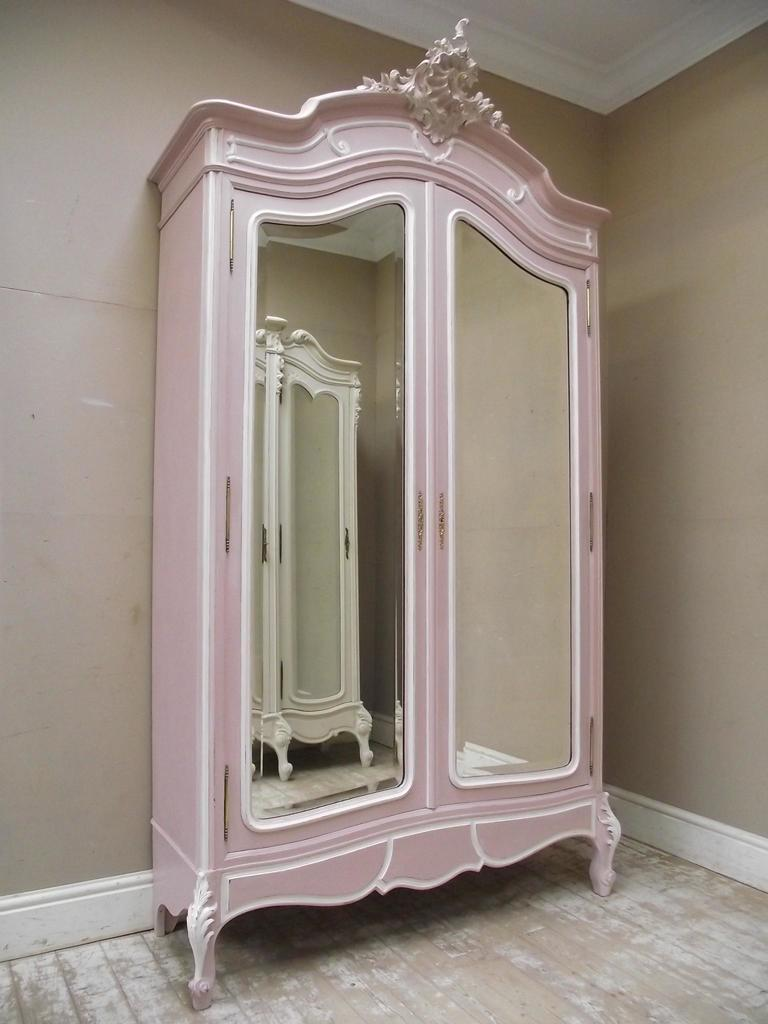What color is the cupboard in the image? The cupboard in the image is pink. What color are the walls in the room? The walls in the room are cream-colored. What color is the roof in the room? The roof in the room is white. How many legs does the fish have in the image? There is no fish present in the image, so it is not possible to determine the number of legs it might have. 